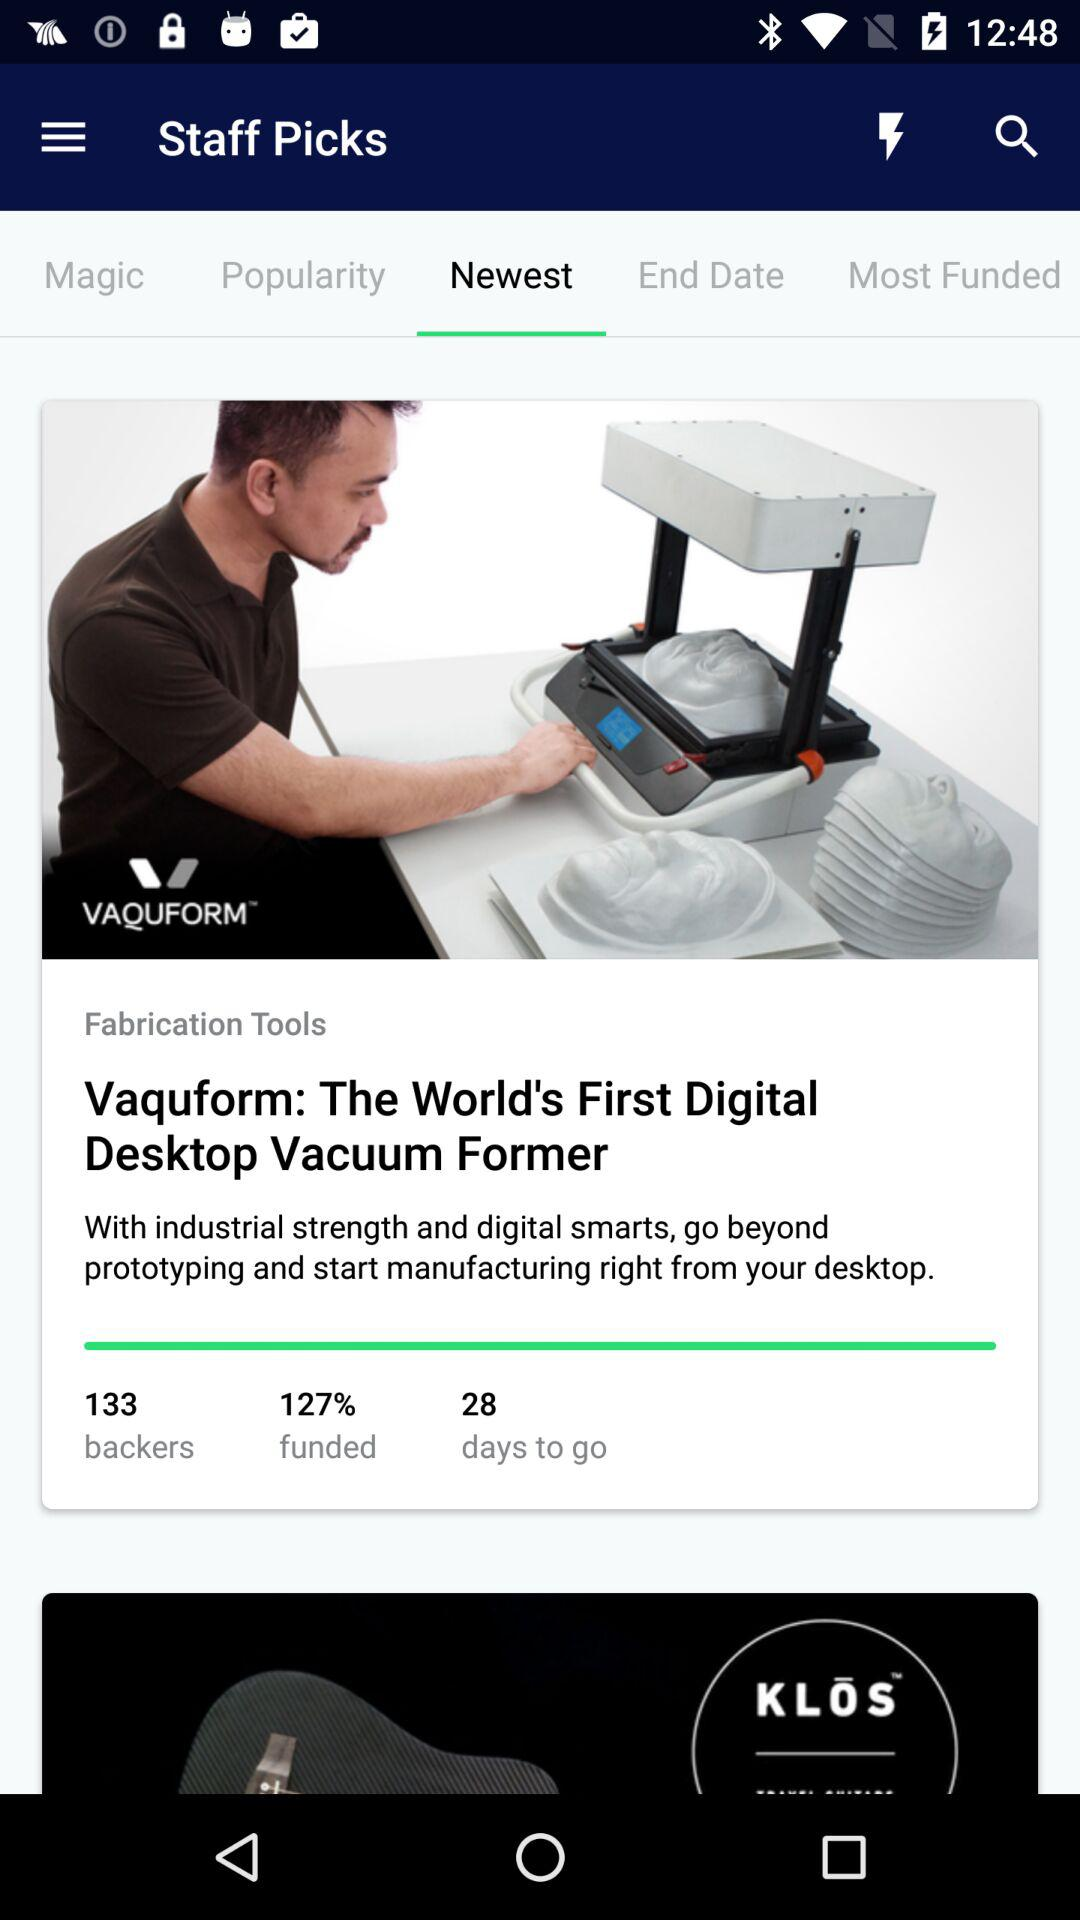How many more days are left until the campaign ends?
Answer the question using a single word or phrase. 28 